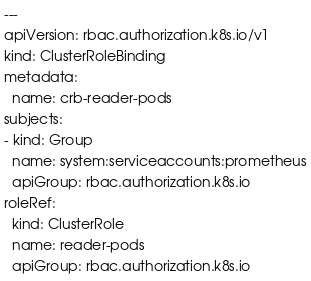<code> <loc_0><loc_0><loc_500><loc_500><_YAML_>---
apiVersion: rbac.authorization.k8s.io/v1
kind: ClusterRoleBinding
metadata:
  name: crb-reader-pods
subjects:
- kind: Group
  name: system:serviceaccounts:prometheus
  apiGroup: rbac.authorization.k8s.io
roleRef:
  kind: ClusterRole
  name: reader-pods
  apiGroup: rbac.authorization.k8s.io
</code> 